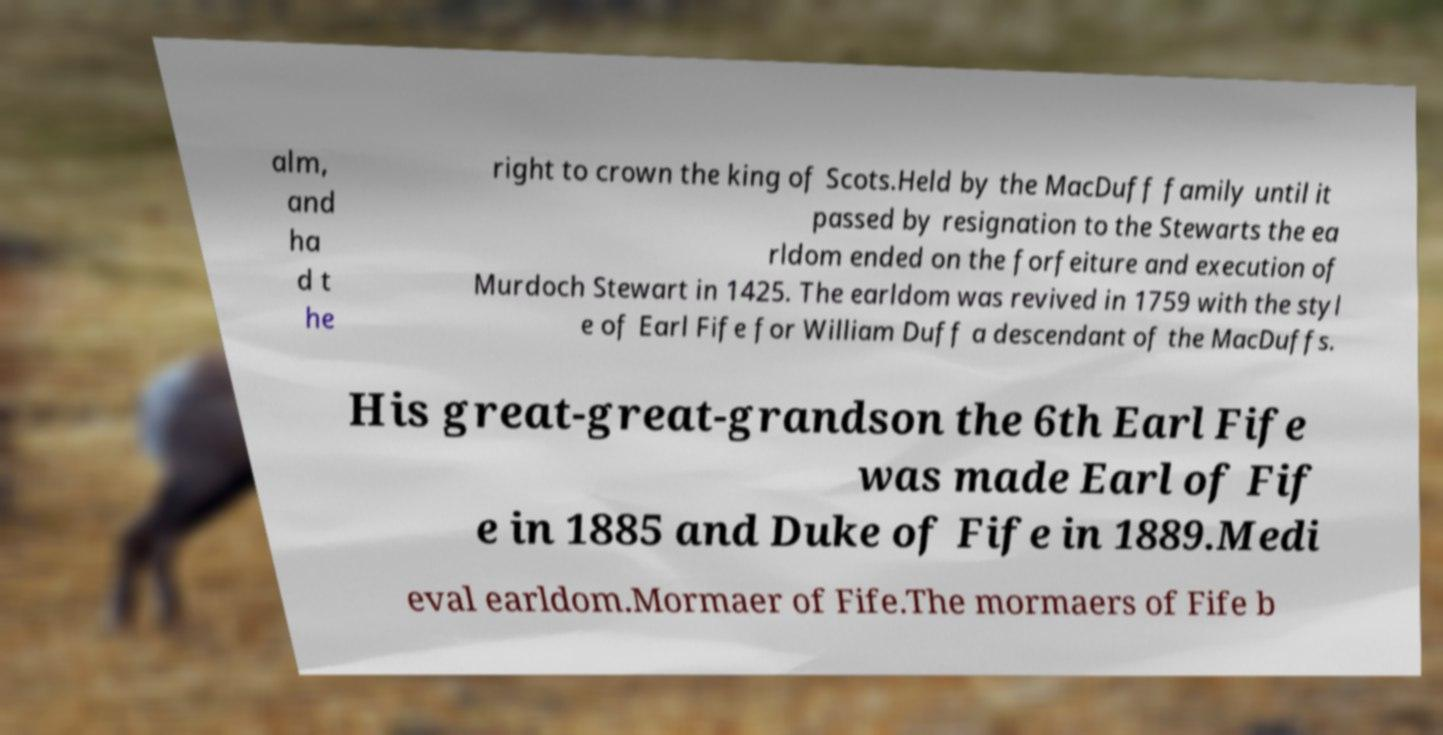What messages or text are displayed in this image? I need them in a readable, typed format. alm, and ha d t he right to crown the king of Scots.Held by the MacDuff family until it passed by resignation to the Stewarts the ea rldom ended on the forfeiture and execution of Murdoch Stewart in 1425. The earldom was revived in 1759 with the styl e of Earl Fife for William Duff a descendant of the MacDuffs. His great-great-grandson the 6th Earl Fife was made Earl of Fif e in 1885 and Duke of Fife in 1889.Medi eval earldom.Mormaer of Fife.The mormaers of Fife b 